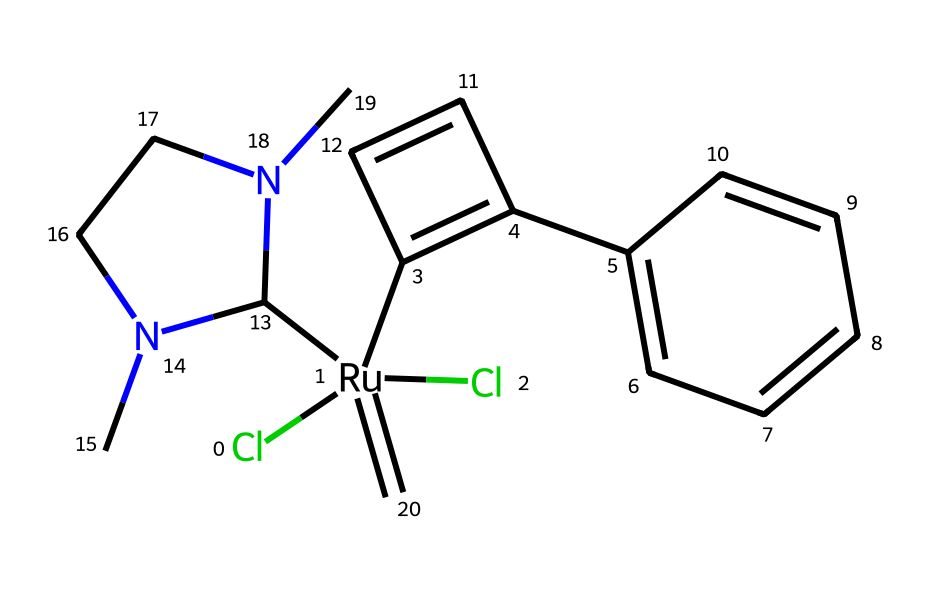What is the central metal atom in this structure? The central metal atom in this organometallic complex is identified as Ruthenium, which is indicated by the 'Ru' in the SMILES representation.
Answer: Ruthenium How many chlorine atoms are present in this chemical? The chemical structure includes two chlorine atoms as indicated by the "Cl" found twice in the SMILES representation.
Answer: 2 What type of reaction is this catalyst primarily used for? Grubbs' catalyst is primarily used for olefin metathesis, which is a reaction involving the reorganization of carbon-carbon double bonds.
Answer: olefin metathesis How many rings are in the structure? The structure contains two rings: one in the cycloalkene (C1=C(...)) and another in the aromatic system (c2ccccc2), leading to a total of two rings.
Answer: 2 What is the coordination number of the central metal in this catalyst? The central metal, Ruthenium, is coordinated by four different groups (2 Cl, 1 alkene, and 1 amine), giving a total coordination number of four.
Answer: 4 What functional group is present in the ligand attached to Ruthenium? The ligand contains a nitrogen-containing amine functional group, which can be identified by the presence of "N(C)" in the SMILES.
Answer: amine Which segment in the structure indicates the presence of an aromatic system? The segment "c2ccccc2" in the SMILES indicates the presence of an aromatic benzene ring, characterized by alternating single and double bonds.
Answer: benzene ring 